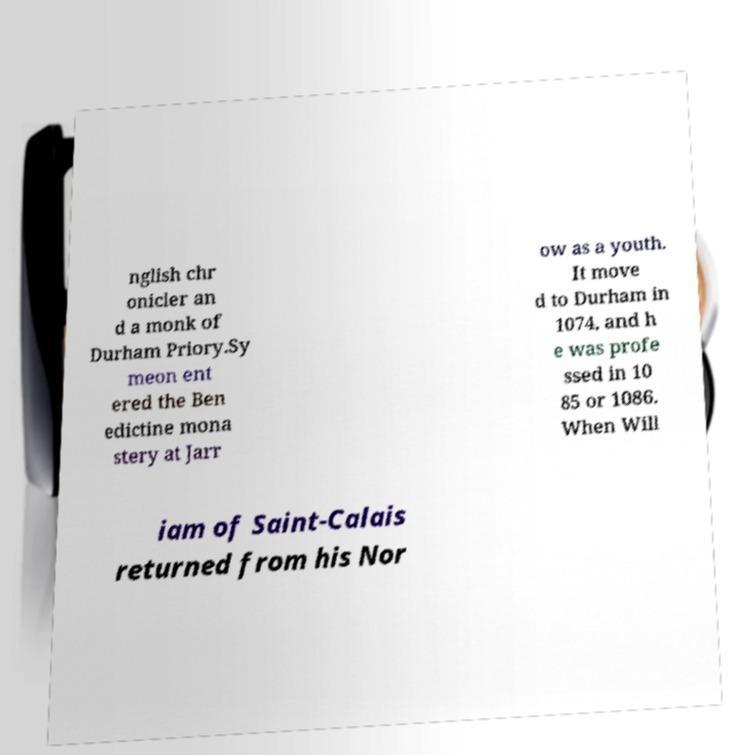Could you extract and type out the text from this image? nglish chr onicler an d a monk of Durham Priory.Sy meon ent ered the Ben edictine mona stery at Jarr ow as a youth. It move d to Durham in 1074, and h e was profe ssed in 10 85 or 1086. When Will iam of Saint-Calais returned from his Nor 